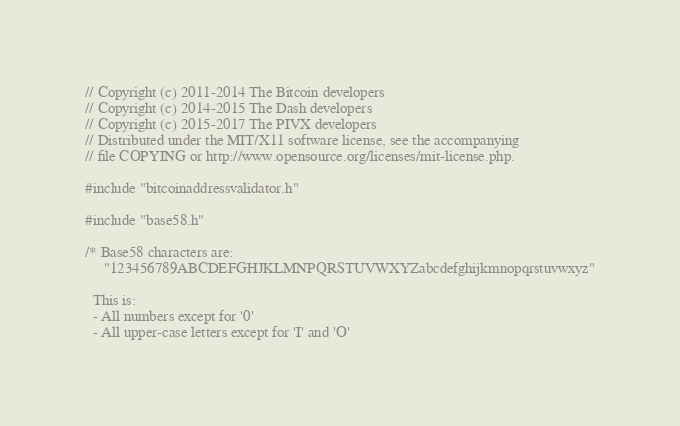<code> <loc_0><loc_0><loc_500><loc_500><_C++_>// Copyright (c) 2011-2014 The Bitcoin developers
// Copyright (c) 2014-2015 The Dash developers
// Copyright (c) 2015-2017 The PIVX developers
// Distributed under the MIT/X11 software license, see the accompanying
// file COPYING or http://www.opensource.org/licenses/mit-license.php.

#include "bitcoinaddressvalidator.h"

#include "base58.h"

/* Base58 characters are:
     "123456789ABCDEFGHJKLMNPQRSTUVWXYZabcdefghijkmnopqrstuvwxyz"

  This is:
  - All numbers except for '0'
  - All upper-case letters except for 'I' and 'O'</code> 